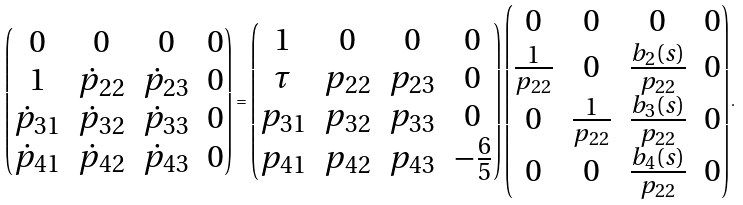Convert formula to latex. <formula><loc_0><loc_0><loc_500><loc_500>\begin{pmatrix} 0 & 0 & 0 & 0 \\ 1 & \dot { p } _ { 2 2 } & \dot { p } _ { 2 3 } & 0 \\ \dot { p } _ { 3 1 } & \dot { p } _ { 3 2 } & \dot { p } _ { 3 3 } & 0 \\ \dot { p } _ { 4 1 } & \dot { p } _ { 4 2 } & \dot { p } _ { 4 3 } & 0 \end{pmatrix} = \begin{pmatrix} 1 & 0 & 0 & 0 \\ \tau & p _ { 2 2 } & p _ { 2 3 } & 0 \\ p _ { 3 1 } & p _ { 3 2 } & p _ { 3 3 } & 0 \\ p _ { 4 1 } & p _ { 4 2 } & p _ { 4 3 } & - \frac { 6 } { 5 } \end{pmatrix} \begin{pmatrix} 0 & 0 & 0 & 0 \\ \frac { 1 } { p _ { 2 2 } } & 0 & \frac { b _ { 2 } ( s ) } { p _ { 2 2 } } & 0 \\ 0 & \frac { 1 } { p _ { 2 2 } } & \frac { b _ { 3 } ( s ) } { p _ { 2 2 } } & 0 \\ 0 & 0 & \frac { b _ { 4 } ( s ) } { p _ { 2 2 } } & 0 \end{pmatrix} .</formula> 